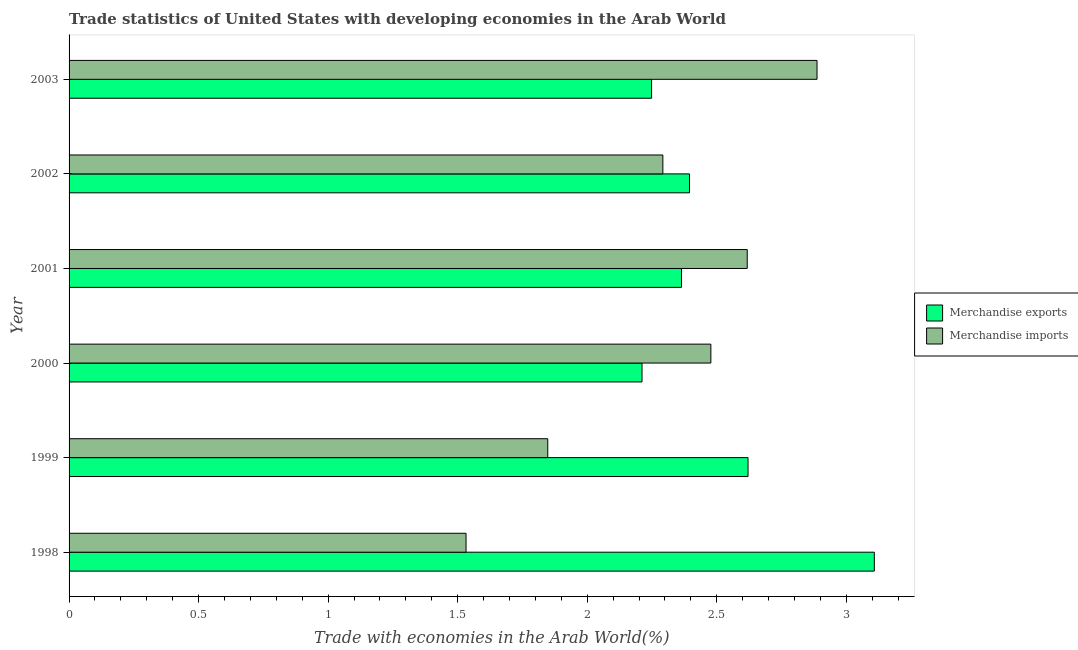How many different coloured bars are there?
Give a very brief answer. 2. How many groups of bars are there?
Your answer should be very brief. 6. Are the number of bars per tick equal to the number of legend labels?
Offer a very short reply. Yes. Are the number of bars on each tick of the Y-axis equal?
Offer a terse response. Yes. How many bars are there on the 2nd tick from the top?
Keep it short and to the point. 2. What is the merchandise exports in 2001?
Your answer should be compact. 2.36. Across all years, what is the maximum merchandise imports?
Your answer should be compact. 2.89. Across all years, what is the minimum merchandise exports?
Provide a succinct answer. 2.21. In which year was the merchandise imports maximum?
Keep it short and to the point. 2003. In which year was the merchandise imports minimum?
Keep it short and to the point. 1998. What is the total merchandise imports in the graph?
Your response must be concise. 13.65. What is the difference between the merchandise imports in 1998 and that in 2000?
Offer a very short reply. -0.94. What is the difference between the merchandise exports in 2001 and the merchandise imports in 2000?
Provide a short and direct response. -0.11. What is the average merchandise imports per year?
Make the answer very short. 2.28. In the year 2000, what is the difference between the merchandise imports and merchandise exports?
Your answer should be compact. 0.27. What is the ratio of the merchandise exports in 2001 to that in 2002?
Give a very brief answer. 0.99. Is the difference between the merchandise exports in 1998 and 2002 greater than the difference between the merchandise imports in 1998 and 2002?
Your response must be concise. Yes. What is the difference between the highest and the second highest merchandise exports?
Offer a very short reply. 0.49. What is the difference between the highest and the lowest merchandise imports?
Your response must be concise. 1.35. What does the 2nd bar from the bottom in 1999 represents?
Your answer should be compact. Merchandise imports. How many bars are there?
Make the answer very short. 12. What is the difference between two consecutive major ticks on the X-axis?
Give a very brief answer. 0.5. Are the values on the major ticks of X-axis written in scientific E-notation?
Provide a short and direct response. No. Does the graph contain any zero values?
Your answer should be compact. No. Does the graph contain grids?
Provide a short and direct response. No. Where does the legend appear in the graph?
Your answer should be compact. Center right. What is the title of the graph?
Give a very brief answer. Trade statistics of United States with developing economies in the Arab World. What is the label or title of the X-axis?
Give a very brief answer. Trade with economies in the Arab World(%). What is the label or title of the Y-axis?
Offer a terse response. Year. What is the Trade with economies in the Arab World(%) of Merchandise exports in 1998?
Provide a succinct answer. 3.11. What is the Trade with economies in the Arab World(%) in Merchandise imports in 1998?
Your answer should be compact. 1.53. What is the Trade with economies in the Arab World(%) of Merchandise exports in 1999?
Provide a short and direct response. 2.62. What is the Trade with economies in the Arab World(%) in Merchandise imports in 1999?
Provide a short and direct response. 1.85. What is the Trade with economies in the Arab World(%) of Merchandise exports in 2000?
Make the answer very short. 2.21. What is the Trade with economies in the Arab World(%) in Merchandise imports in 2000?
Offer a very short reply. 2.48. What is the Trade with economies in the Arab World(%) of Merchandise exports in 2001?
Your answer should be compact. 2.36. What is the Trade with economies in the Arab World(%) in Merchandise imports in 2001?
Provide a succinct answer. 2.62. What is the Trade with economies in the Arab World(%) of Merchandise exports in 2002?
Make the answer very short. 2.39. What is the Trade with economies in the Arab World(%) in Merchandise imports in 2002?
Provide a short and direct response. 2.29. What is the Trade with economies in the Arab World(%) of Merchandise exports in 2003?
Provide a succinct answer. 2.25. What is the Trade with economies in the Arab World(%) in Merchandise imports in 2003?
Your answer should be compact. 2.89. Across all years, what is the maximum Trade with economies in the Arab World(%) in Merchandise exports?
Offer a terse response. 3.11. Across all years, what is the maximum Trade with economies in the Arab World(%) in Merchandise imports?
Your response must be concise. 2.89. Across all years, what is the minimum Trade with economies in the Arab World(%) in Merchandise exports?
Keep it short and to the point. 2.21. Across all years, what is the minimum Trade with economies in the Arab World(%) in Merchandise imports?
Give a very brief answer. 1.53. What is the total Trade with economies in the Arab World(%) in Merchandise exports in the graph?
Make the answer very short. 14.95. What is the total Trade with economies in the Arab World(%) in Merchandise imports in the graph?
Your response must be concise. 13.65. What is the difference between the Trade with economies in the Arab World(%) of Merchandise exports in 1998 and that in 1999?
Keep it short and to the point. 0.49. What is the difference between the Trade with economies in the Arab World(%) of Merchandise imports in 1998 and that in 1999?
Offer a very short reply. -0.32. What is the difference between the Trade with economies in the Arab World(%) in Merchandise exports in 1998 and that in 2000?
Ensure brevity in your answer.  0.9. What is the difference between the Trade with economies in the Arab World(%) in Merchandise imports in 1998 and that in 2000?
Provide a short and direct response. -0.94. What is the difference between the Trade with economies in the Arab World(%) in Merchandise exports in 1998 and that in 2001?
Keep it short and to the point. 0.74. What is the difference between the Trade with economies in the Arab World(%) in Merchandise imports in 1998 and that in 2001?
Your response must be concise. -1.09. What is the difference between the Trade with economies in the Arab World(%) of Merchandise exports in 1998 and that in 2002?
Your answer should be compact. 0.71. What is the difference between the Trade with economies in the Arab World(%) of Merchandise imports in 1998 and that in 2002?
Your answer should be compact. -0.76. What is the difference between the Trade with economies in the Arab World(%) in Merchandise exports in 1998 and that in 2003?
Your response must be concise. 0.86. What is the difference between the Trade with economies in the Arab World(%) of Merchandise imports in 1998 and that in 2003?
Your answer should be very brief. -1.35. What is the difference between the Trade with economies in the Arab World(%) of Merchandise exports in 1999 and that in 2000?
Your answer should be compact. 0.41. What is the difference between the Trade with economies in the Arab World(%) of Merchandise imports in 1999 and that in 2000?
Make the answer very short. -0.63. What is the difference between the Trade with economies in the Arab World(%) of Merchandise exports in 1999 and that in 2001?
Your answer should be compact. 0.26. What is the difference between the Trade with economies in the Arab World(%) of Merchandise imports in 1999 and that in 2001?
Your response must be concise. -0.77. What is the difference between the Trade with economies in the Arab World(%) in Merchandise exports in 1999 and that in 2002?
Ensure brevity in your answer.  0.23. What is the difference between the Trade with economies in the Arab World(%) of Merchandise imports in 1999 and that in 2002?
Give a very brief answer. -0.44. What is the difference between the Trade with economies in the Arab World(%) in Merchandise exports in 1999 and that in 2003?
Keep it short and to the point. 0.37. What is the difference between the Trade with economies in the Arab World(%) in Merchandise imports in 1999 and that in 2003?
Ensure brevity in your answer.  -1.04. What is the difference between the Trade with economies in the Arab World(%) in Merchandise exports in 2000 and that in 2001?
Your answer should be compact. -0.15. What is the difference between the Trade with economies in the Arab World(%) in Merchandise imports in 2000 and that in 2001?
Offer a terse response. -0.14. What is the difference between the Trade with economies in the Arab World(%) in Merchandise exports in 2000 and that in 2002?
Your answer should be compact. -0.18. What is the difference between the Trade with economies in the Arab World(%) of Merchandise imports in 2000 and that in 2002?
Offer a terse response. 0.19. What is the difference between the Trade with economies in the Arab World(%) of Merchandise exports in 2000 and that in 2003?
Offer a very short reply. -0.04. What is the difference between the Trade with economies in the Arab World(%) in Merchandise imports in 2000 and that in 2003?
Ensure brevity in your answer.  -0.41. What is the difference between the Trade with economies in the Arab World(%) in Merchandise exports in 2001 and that in 2002?
Keep it short and to the point. -0.03. What is the difference between the Trade with economies in the Arab World(%) of Merchandise imports in 2001 and that in 2002?
Offer a terse response. 0.33. What is the difference between the Trade with economies in the Arab World(%) of Merchandise exports in 2001 and that in 2003?
Offer a terse response. 0.12. What is the difference between the Trade with economies in the Arab World(%) of Merchandise imports in 2001 and that in 2003?
Provide a succinct answer. -0.27. What is the difference between the Trade with economies in the Arab World(%) in Merchandise exports in 2002 and that in 2003?
Make the answer very short. 0.15. What is the difference between the Trade with economies in the Arab World(%) of Merchandise imports in 2002 and that in 2003?
Your answer should be compact. -0.6. What is the difference between the Trade with economies in the Arab World(%) of Merchandise exports in 1998 and the Trade with economies in the Arab World(%) of Merchandise imports in 1999?
Keep it short and to the point. 1.26. What is the difference between the Trade with economies in the Arab World(%) in Merchandise exports in 1998 and the Trade with economies in the Arab World(%) in Merchandise imports in 2000?
Your response must be concise. 0.63. What is the difference between the Trade with economies in the Arab World(%) in Merchandise exports in 1998 and the Trade with economies in the Arab World(%) in Merchandise imports in 2001?
Make the answer very short. 0.49. What is the difference between the Trade with economies in the Arab World(%) of Merchandise exports in 1998 and the Trade with economies in the Arab World(%) of Merchandise imports in 2002?
Keep it short and to the point. 0.82. What is the difference between the Trade with economies in the Arab World(%) of Merchandise exports in 1998 and the Trade with economies in the Arab World(%) of Merchandise imports in 2003?
Give a very brief answer. 0.22. What is the difference between the Trade with economies in the Arab World(%) of Merchandise exports in 1999 and the Trade with economies in the Arab World(%) of Merchandise imports in 2000?
Your response must be concise. 0.14. What is the difference between the Trade with economies in the Arab World(%) of Merchandise exports in 1999 and the Trade with economies in the Arab World(%) of Merchandise imports in 2001?
Offer a very short reply. 0. What is the difference between the Trade with economies in the Arab World(%) in Merchandise exports in 1999 and the Trade with economies in the Arab World(%) in Merchandise imports in 2002?
Keep it short and to the point. 0.33. What is the difference between the Trade with economies in the Arab World(%) in Merchandise exports in 1999 and the Trade with economies in the Arab World(%) in Merchandise imports in 2003?
Your answer should be very brief. -0.27. What is the difference between the Trade with economies in the Arab World(%) in Merchandise exports in 2000 and the Trade with economies in the Arab World(%) in Merchandise imports in 2001?
Provide a succinct answer. -0.41. What is the difference between the Trade with economies in the Arab World(%) in Merchandise exports in 2000 and the Trade with economies in the Arab World(%) in Merchandise imports in 2002?
Ensure brevity in your answer.  -0.08. What is the difference between the Trade with economies in the Arab World(%) in Merchandise exports in 2000 and the Trade with economies in the Arab World(%) in Merchandise imports in 2003?
Make the answer very short. -0.68. What is the difference between the Trade with economies in the Arab World(%) of Merchandise exports in 2001 and the Trade with economies in the Arab World(%) of Merchandise imports in 2002?
Ensure brevity in your answer.  0.07. What is the difference between the Trade with economies in the Arab World(%) of Merchandise exports in 2001 and the Trade with economies in the Arab World(%) of Merchandise imports in 2003?
Your answer should be compact. -0.52. What is the difference between the Trade with economies in the Arab World(%) in Merchandise exports in 2002 and the Trade with economies in the Arab World(%) in Merchandise imports in 2003?
Ensure brevity in your answer.  -0.49. What is the average Trade with economies in the Arab World(%) of Merchandise exports per year?
Provide a short and direct response. 2.49. What is the average Trade with economies in the Arab World(%) in Merchandise imports per year?
Offer a terse response. 2.28. In the year 1998, what is the difference between the Trade with economies in the Arab World(%) of Merchandise exports and Trade with economies in the Arab World(%) of Merchandise imports?
Your response must be concise. 1.58. In the year 1999, what is the difference between the Trade with economies in the Arab World(%) of Merchandise exports and Trade with economies in the Arab World(%) of Merchandise imports?
Your response must be concise. 0.77. In the year 2000, what is the difference between the Trade with economies in the Arab World(%) in Merchandise exports and Trade with economies in the Arab World(%) in Merchandise imports?
Your answer should be compact. -0.27. In the year 2001, what is the difference between the Trade with economies in the Arab World(%) in Merchandise exports and Trade with economies in the Arab World(%) in Merchandise imports?
Your answer should be compact. -0.25. In the year 2002, what is the difference between the Trade with economies in the Arab World(%) in Merchandise exports and Trade with economies in the Arab World(%) in Merchandise imports?
Make the answer very short. 0.1. In the year 2003, what is the difference between the Trade with economies in the Arab World(%) of Merchandise exports and Trade with economies in the Arab World(%) of Merchandise imports?
Your answer should be very brief. -0.64. What is the ratio of the Trade with economies in the Arab World(%) in Merchandise exports in 1998 to that in 1999?
Offer a terse response. 1.19. What is the ratio of the Trade with economies in the Arab World(%) in Merchandise imports in 1998 to that in 1999?
Give a very brief answer. 0.83. What is the ratio of the Trade with economies in the Arab World(%) of Merchandise exports in 1998 to that in 2000?
Make the answer very short. 1.41. What is the ratio of the Trade with economies in the Arab World(%) in Merchandise imports in 1998 to that in 2000?
Offer a terse response. 0.62. What is the ratio of the Trade with economies in the Arab World(%) of Merchandise exports in 1998 to that in 2001?
Ensure brevity in your answer.  1.31. What is the ratio of the Trade with economies in the Arab World(%) of Merchandise imports in 1998 to that in 2001?
Ensure brevity in your answer.  0.59. What is the ratio of the Trade with economies in the Arab World(%) of Merchandise exports in 1998 to that in 2002?
Give a very brief answer. 1.3. What is the ratio of the Trade with economies in the Arab World(%) of Merchandise imports in 1998 to that in 2002?
Offer a very short reply. 0.67. What is the ratio of the Trade with economies in the Arab World(%) in Merchandise exports in 1998 to that in 2003?
Your response must be concise. 1.38. What is the ratio of the Trade with economies in the Arab World(%) in Merchandise imports in 1998 to that in 2003?
Your answer should be compact. 0.53. What is the ratio of the Trade with economies in the Arab World(%) in Merchandise exports in 1999 to that in 2000?
Offer a very short reply. 1.19. What is the ratio of the Trade with economies in the Arab World(%) in Merchandise imports in 1999 to that in 2000?
Make the answer very short. 0.75. What is the ratio of the Trade with economies in the Arab World(%) of Merchandise exports in 1999 to that in 2001?
Make the answer very short. 1.11. What is the ratio of the Trade with economies in the Arab World(%) in Merchandise imports in 1999 to that in 2001?
Provide a short and direct response. 0.71. What is the ratio of the Trade with economies in the Arab World(%) of Merchandise exports in 1999 to that in 2002?
Offer a terse response. 1.09. What is the ratio of the Trade with economies in the Arab World(%) in Merchandise imports in 1999 to that in 2002?
Your response must be concise. 0.81. What is the ratio of the Trade with economies in the Arab World(%) of Merchandise exports in 1999 to that in 2003?
Offer a terse response. 1.17. What is the ratio of the Trade with economies in the Arab World(%) of Merchandise imports in 1999 to that in 2003?
Offer a terse response. 0.64. What is the ratio of the Trade with economies in the Arab World(%) of Merchandise exports in 2000 to that in 2001?
Offer a terse response. 0.94. What is the ratio of the Trade with economies in the Arab World(%) of Merchandise imports in 2000 to that in 2001?
Give a very brief answer. 0.95. What is the ratio of the Trade with economies in the Arab World(%) in Merchandise exports in 2000 to that in 2002?
Your answer should be very brief. 0.92. What is the ratio of the Trade with economies in the Arab World(%) of Merchandise imports in 2000 to that in 2002?
Provide a short and direct response. 1.08. What is the ratio of the Trade with economies in the Arab World(%) in Merchandise exports in 2000 to that in 2003?
Your response must be concise. 0.98. What is the ratio of the Trade with economies in the Arab World(%) of Merchandise imports in 2000 to that in 2003?
Give a very brief answer. 0.86. What is the ratio of the Trade with economies in the Arab World(%) of Merchandise exports in 2001 to that in 2002?
Keep it short and to the point. 0.99. What is the ratio of the Trade with economies in the Arab World(%) in Merchandise imports in 2001 to that in 2002?
Your answer should be compact. 1.14. What is the ratio of the Trade with economies in the Arab World(%) of Merchandise exports in 2001 to that in 2003?
Provide a succinct answer. 1.05. What is the ratio of the Trade with economies in the Arab World(%) in Merchandise imports in 2001 to that in 2003?
Provide a short and direct response. 0.91. What is the ratio of the Trade with economies in the Arab World(%) of Merchandise exports in 2002 to that in 2003?
Ensure brevity in your answer.  1.07. What is the ratio of the Trade with economies in the Arab World(%) in Merchandise imports in 2002 to that in 2003?
Give a very brief answer. 0.79. What is the difference between the highest and the second highest Trade with economies in the Arab World(%) in Merchandise exports?
Make the answer very short. 0.49. What is the difference between the highest and the second highest Trade with economies in the Arab World(%) of Merchandise imports?
Keep it short and to the point. 0.27. What is the difference between the highest and the lowest Trade with economies in the Arab World(%) of Merchandise exports?
Your response must be concise. 0.9. What is the difference between the highest and the lowest Trade with economies in the Arab World(%) of Merchandise imports?
Keep it short and to the point. 1.35. 